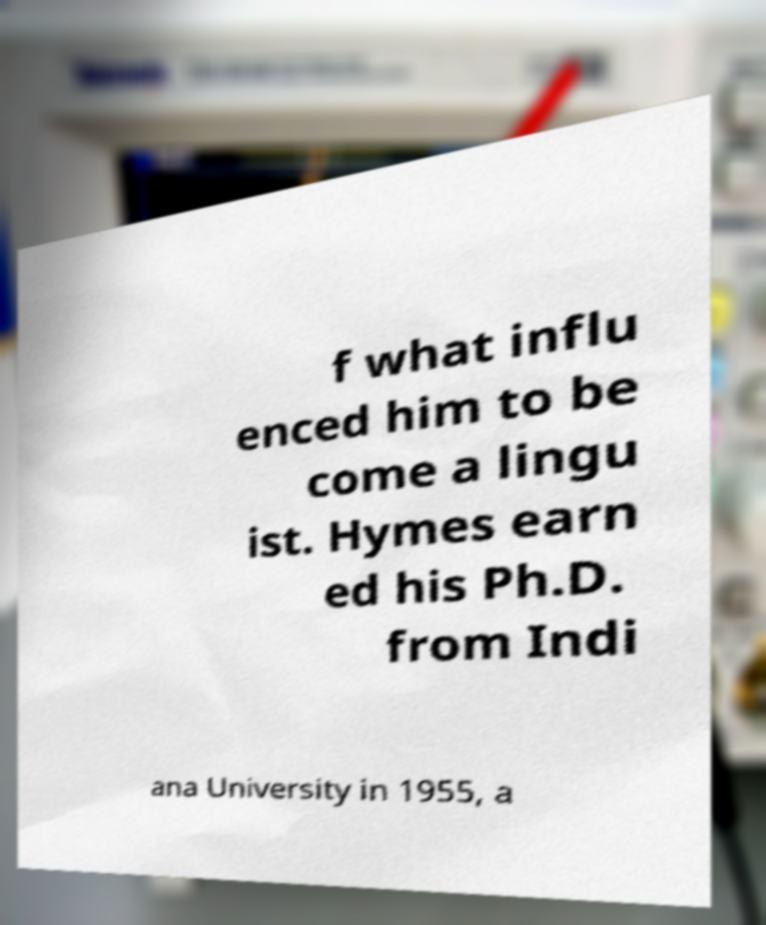Please read and relay the text visible in this image. What does it say? f what influ enced him to be come a lingu ist. Hymes earn ed his Ph.D. from Indi ana University in 1955, a 